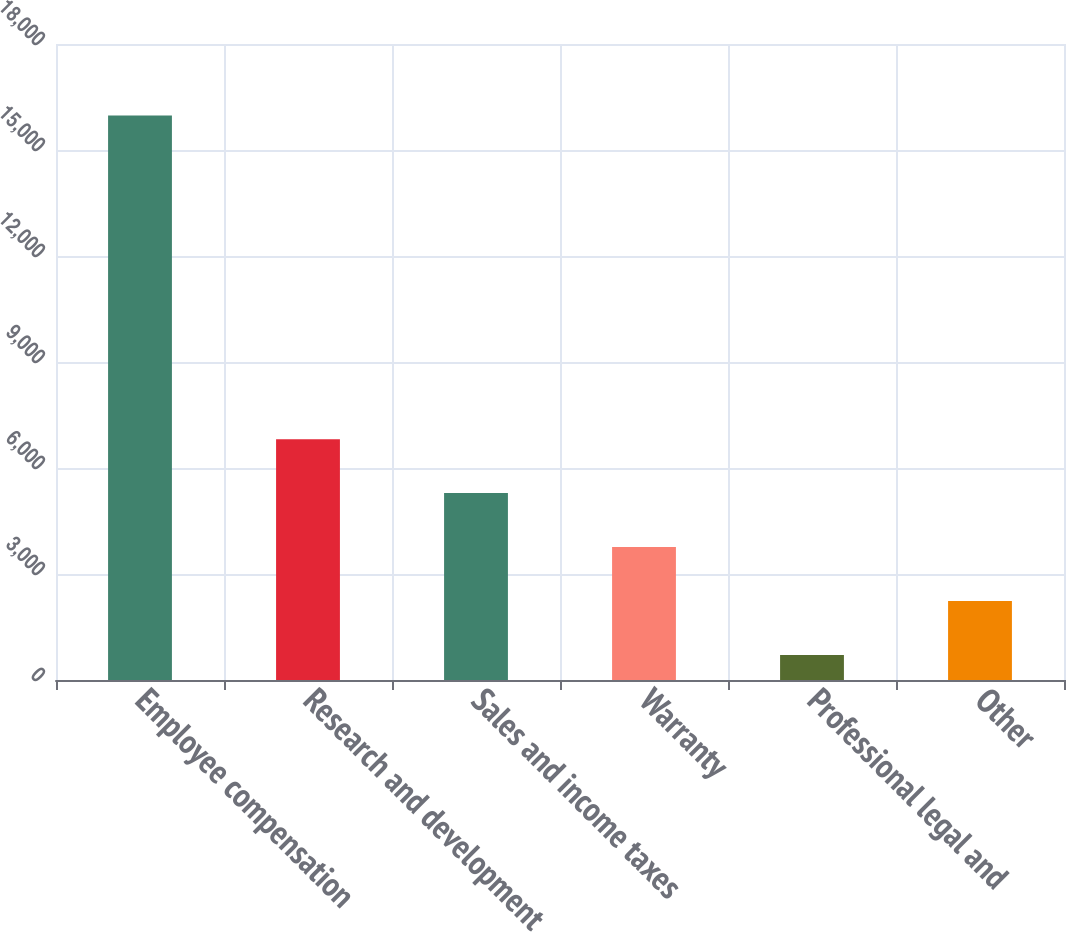Convert chart. <chart><loc_0><loc_0><loc_500><loc_500><bar_chart><fcel>Employee compensation<fcel>Research and development<fcel>Sales and income taxes<fcel>Warranty<fcel>Professional legal and<fcel>Other<nl><fcel>15978<fcel>6817.2<fcel>5290.4<fcel>3763.6<fcel>710<fcel>2236.8<nl></chart> 